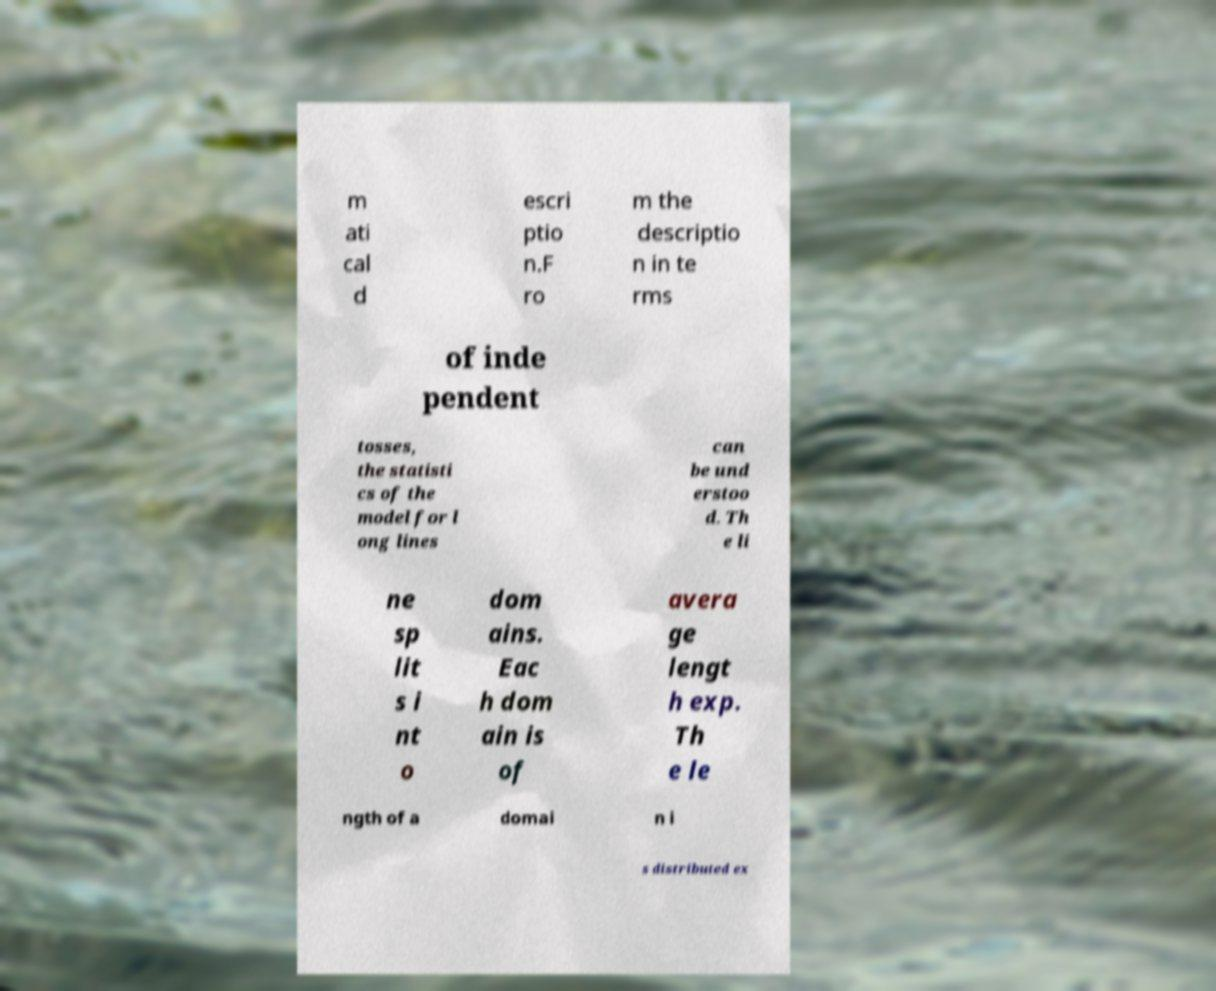Could you assist in decoding the text presented in this image and type it out clearly? m ati cal d escri ptio n.F ro m the descriptio n in te rms of inde pendent tosses, the statisti cs of the model for l ong lines can be und erstoo d. Th e li ne sp lit s i nt o dom ains. Eac h dom ain is of avera ge lengt h exp. Th e le ngth of a domai n i s distributed ex 